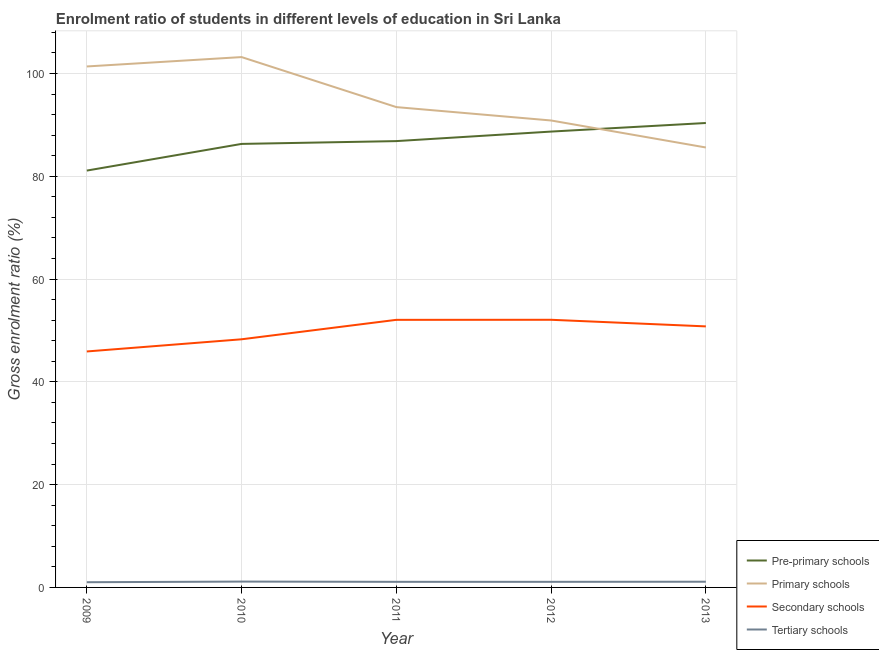Is the number of lines equal to the number of legend labels?
Provide a short and direct response. Yes. What is the gross enrolment ratio in pre-primary schools in 2013?
Keep it short and to the point. 90.36. Across all years, what is the maximum gross enrolment ratio in primary schools?
Make the answer very short. 103.19. Across all years, what is the minimum gross enrolment ratio in secondary schools?
Your answer should be compact. 45.91. In which year was the gross enrolment ratio in pre-primary schools maximum?
Offer a very short reply. 2013. What is the total gross enrolment ratio in secondary schools in the graph?
Give a very brief answer. 249.12. What is the difference between the gross enrolment ratio in primary schools in 2011 and that in 2012?
Keep it short and to the point. 2.6. What is the difference between the gross enrolment ratio in tertiary schools in 2011 and the gross enrolment ratio in pre-primary schools in 2013?
Offer a terse response. -89.27. What is the average gross enrolment ratio in primary schools per year?
Keep it short and to the point. 94.89. In the year 2011, what is the difference between the gross enrolment ratio in pre-primary schools and gross enrolment ratio in tertiary schools?
Keep it short and to the point. 85.75. What is the ratio of the gross enrolment ratio in pre-primary schools in 2010 to that in 2013?
Ensure brevity in your answer.  0.95. Is the gross enrolment ratio in primary schools in 2012 less than that in 2013?
Your response must be concise. No. What is the difference between the highest and the second highest gross enrolment ratio in tertiary schools?
Your answer should be very brief. 0.03. What is the difference between the highest and the lowest gross enrolment ratio in secondary schools?
Your response must be concise. 6.16. What is the difference between two consecutive major ticks on the Y-axis?
Provide a short and direct response. 20. Are the values on the major ticks of Y-axis written in scientific E-notation?
Provide a succinct answer. No. Does the graph contain any zero values?
Make the answer very short. No. Does the graph contain grids?
Provide a short and direct response. Yes. Where does the legend appear in the graph?
Give a very brief answer. Bottom right. How many legend labels are there?
Your response must be concise. 4. What is the title of the graph?
Ensure brevity in your answer.  Enrolment ratio of students in different levels of education in Sri Lanka. Does "Ease of arranging shipments" appear as one of the legend labels in the graph?
Offer a terse response. No. What is the label or title of the Y-axis?
Your answer should be compact. Gross enrolment ratio (%). What is the Gross enrolment ratio (%) in Pre-primary schools in 2009?
Make the answer very short. 81.1. What is the Gross enrolment ratio (%) of Primary schools in 2009?
Keep it short and to the point. 101.36. What is the Gross enrolment ratio (%) in Secondary schools in 2009?
Offer a very short reply. 45.91. What is the Gross enrolment ratio (%) in Tertiary schools in 2009?
Offer a terse response. 1.01. What is the Gross enrolment ratio (%) of Pre-primary schools in 2010?
Make the answer very short. 86.29. What is the Gross enrolment ratio (%) of Primary schools in 2010?
Ensure brevity in your answer.  103.19. What is the Gross enrolment ratio (%) in Secondary schools in 2010?
Give a very brief answer. 48.28. What is the Gross enrolment ratio (%) of Tertiary schools in 2010?
Provide a succinct answer. 1.14. What is the Gross enrolment ratio (%) of Pre-primary schools in 2011?
Ensure brevity in your answer.  86.84. What is the Gross enrolment ratio (%) in Primary schools in 2011?
Your response must be concise. 93.46. What is the Gross enrolment ratio (%) of Secondary schools in 2011?
Keep it short and to the point. 52.06. What is the Gross enrolment ratio (%) of Tertiary schools in 2011?
Provide a short and direct response. 1.09. What is the Gross enrolment ratio (%) of Pre-primary schools in 2012?
Offer a very short reply. 88.69. What is the Gross enrolment ratio (%) in Primary schools in 2012?
Your response must be concise. 90.85. What is the Gross enrolment ratio (%) of Secondary schools in 2012?
Make the answer very short. 52.08. What is the Gross enrolment ratio (%) in Tertiary schools in 2012?
Provide a short and direct response. 1.09. What is the Gross enrolment ratio (%) of Pre-primary schools in 2013?
Provide a short and direct response. 90.36. What is the Gross enrolment ratio (%) in Primary schools in 2013?
Your response must be concise. 85.6. What is the Gross enrolment ratio (%) in Secondary schools in 2013?
Give a very brief answer. 50.79. What is the Gross enrolment ratio (%) of Tertiary schools in 2013?
Give a very brief answer. 1.11. Across all years, what is the maximum Gross enrolment ratio (%) in Pre-primary schools?
Make the answer very short. 90.36. Across all years, what is the maximum Gross enrolment ratio (%) in Primary schools?
Your answer should be very brief. 103.19. Across all years, what is the maximum Gross enrolment ratio (%) in Secondary schools?
Offer a terse response. 52.08. Across all years, what is the maximum Gross enrolment ratio (%) in Tertiary schools?
Offer a very short reply. 1.14. Across all years, what is the minimum Gross enrolment ratio (%) in Pre-primary schools?
Offer a very short reply. 81.1. Across all years, what is the minimum Gross enrolment ratio (%) of Primary schools?
Ensure brevity in your answer.  85.6. Across all years, what is the minimum Gross enrolment ratio (%) in Secondary schools?
Make the answer very short. 45.91. Across all years, what is the minimum Gross enrolment ratio (%) in Tertiary schools?
Offer a very short reply. 1.01. What is the total Gross enrolment ratio (%) of Pre-primary schools in the graph?
Provide a succinct answer. 433.29. What is the total Gross enrolment ratio (%) of Primary schools in the graph?
Give a very brief answer. 474.45. What is the total Gross enrolment ratio (%) of Secondary schools in the graph?
Your answer should be very brief. 249.12. What is the total Gross enrolment ratio (%) of Tertiary schools in the graph?
Make the answer very short. 5.44. What is the difference between the Gross enrolment ratio (%) in Pre-primary schools in 2009 and that in 2010?
Your answer should be compact. -5.19. What is the difference between the Gross enrolment ratio (%) in Primary schools in 2009 and that in 2010?
Offer a terse response. -1.83. What is the difference between the Gross enrolment ratio (%) in Secondary schools in 2009 and that in 2010?
Your answer should be very brief. -2.37. What is the difference between the Gross enrolment ratio (%) in Tertiary schools in 2009 and that in 2010?
Your answer should be compact. -0.12. What is the difference between the Gross enrolment ratio (%) of Pre-primary schools in 2009 and that in 2011?
Keep it short and to the point. -5.73. What is the difference between the Gross enrolment ratio (%) in Primary schools in 2009 and that in 2011?
Keep it short and to the point. 7.91. What is the difference between the Gross enrolment ratio (%) in Secondary schools in 2009 and that in 2011?
Provide a short and direct response. -6.15. What is the difference between the Gross enrolment ratio (%) in Tertiary schools in 2009 and that in 2011?
Offer a terse response. -0.08. What is the difference between the Gross enrolment ratio (%) of Pre-primary schools in 2009 and that in 2012?
Provide a short and direct response. -7.59. What is the difference between the Gross enrolment ratio (%) of Primary schools in 2009 and that in 2012?
Offer a terse response. 10.51. What is the difference between the Gross enrolment ratio (%) in Secondary schools in 2009 and that in 2012?
Your answer should be very brief. -6.16. What is the difference between the Gross enrolment ratio (%) of Tertiary schools in 2009 and that in 2012?
Offer a terse response. -0.08. What is the difference between the Gross enrolment ratio (%) of Pre-primary schools in 2009 and that in 2013?
Give a very brief answer. -9.26. What is the difference between the Gross enrolment ratio (%) in Primary schools in 2009 and that in 2013?
Provide a short and direct response. 15.76. What is the difference between the Gross enrolment ratio (%) of Secondary schools in 2009 and that in 2013?
Ensure brevity in your answer.  -4.88. What is the difference between the Gross enrolment ratio (%) of Tertiary schools in 2009 and that in 2013?
Provide a short and direct response. -0.1. What is the difference between the Gross enrolment ratio (%) of Pre-primary schools in 2010 and that in 2011?
Give a very brief answer. -0.55. What is the difference between the Gross enrolment ratio (%) of Primary schools in 2010 and that in 2011?
Give a very brief answer. 9.73. What is the difference between the Gross enrolment ratio (%) in Secondary schools in 2010 and that in 2011?
Your response must be concise. -3.78. What is the difference between the Gross enrolment ratio (%) of Tertiary schools in 2010 and that in 2011?
Your answer should be very brief. 0.05. What is the difference between the Gross enrolment ratio (%) in Pre-primary schools in 2010 and that in 2012?
Your response must be concise. -2.4. What is the difference between the Gross enrolment ratio (%) in Primary schools in 2010 and that in 2012?
Provide a short and direct response. 12.34. What is the difference between the Gross enrolment ratio (%) in Secondary schools in 2010 and that in 2012?
Your response must be concise. -3.8. What is the difference between the Gross enrolment ratio (%) of Tertiary schools in 2010 and that in 2012?
Your response must be concise. 0.05. What is the difference between the Gross enrolment ratio (%) in Pre-primary schools in 2010 and that in 2013?
Your response must be concise. -4.07. What is the difference between the Gross enrolment ratio (%) in Primary schools in 2010 and that in 2013?
Offer a terse response. 17.59. What is the difference between the Gross enrolment ratio (%) in Secondary schools in 2010 and that in 2013?
Make the answer very short. -2.51. What is the difference between the Gross enrolment ratio (%) in Tertiary schools in 2010 and that in 2013?
Your answer should be compact. 0.03. What is the difference between the Gross enrolment ratio (%) of Pre-primary schools in 2011 and that in 2012?
Ensure brevity in your answer.  -1.85. What is the difference between the Gross enrolment ratio (%) of Primary schools in 2011 and that in 2012?
Provide a succinct answer. 2.6. What is the difference between the Gross enrolment ratio (%) of Secondary schools in 2011 and that in 2012?
Your response must be concise. -0.01. What is the difference between the Gross enrolment ratio (%) in Tertiary schools in 2011 and that in 2012?
Give a very brief answer. -0. What is the difference between the Gross enrolment ratio (%) in Pre-primary schools in 2011 and that in 2013?
Make the answer very short. -3.52. What is the difference between the Gross enrolment ratio (%) of Primary schools in 2011 and that in 2013?
Provide a short and direct response. 7.86. What is the difference between the Gross enrolment ratio (%) of Secondary schools in 2011 and that in 2013?
Ensure brevity in your answer.  1.27. What is the difference between the Gross enrolment ratio (%) of Tertiary schools in 2011 and that in 2013?
Provide a succinct answer. -0.02. What is the difference between the Gross enrolment ratio (%) in Pre-primary schools in 2012 and that in 2013?
Provide a succinct answer. -1.67. What is the difference between the Gross enrolment ratio (%) in Primary schools in 2012 and that in 2013?
Provide a succinct answer. 5.25. What is the difference between the Gross enrolment ratio (%) in Secondary schools in 2012 and that in 2013?
Keep it short and to the point. 1.29. What is the difference between the Gross enrolment ratio (%) in Tertiary schools in 2012 and that in 2013?
Your answer should be very brief. -0.02. What is the difference between the Gross enrolment ratio (%) in Pre-primary schools in 2009 and the Gross enrolment ratio (%) in Primary schools in 2010?
Your answer should be very brief. -22.08. What is the difference between the Gross enrolment ratio (%) in Pre-primary schools in 2009 and the Gross enrolment ratio (%) in Secondary schools in 2010?
Your answer should be compact. 32.83. What is the difference between the Gross enrolment ratio (%) in Pre-primary schools in 2009 and the Gross enrolment ratio (%) in Tertiary schools in 2010?
Your answer should be very brief. 79.97. What is the difference between the Gross enrolment ratio (%) of Primary schools in 2009 and the Gross enrolment ratio (%) of Secondary schools in 2010?
Offer a very short reply. 53.08. What is the difference between the Gross enrolment ratio (%) of Primary schools in 2009 and the Gross enrolment ratio (%) of Tertiary schools in 2010?
Provide a short and direct response. 100.22. What is the difference between the Gross enrolment ratio (%) of Secondary schools in 2009 and the Gross enrolment ratio (%) of Tertiary schools in 2010?
Provide a short and direct response. 44.77. What is the difference between the Gross enrolment ratio (%) in Pre-primary schools in 2009 and the Gross enrolment ratio (%) in Primary schools in 2011?
Make the answer very short. -12.35. What is the difference between the Gross enrolment ratio (%) of Pre-primary schools in 2009 and the Gross enrolment ratio (%) of Secondary schools in 2011?
Provide a succinct answer. 29.04. What is the difference between the Gross enrolment ratio (%) of Pre-primary schools in 2009 and the Gross enrolment ratio (%) of Tertiary schools in 2011?
Provide a succinct answer. 80.02. What is the difference between the Gross enrolment ratio (%) in Primary schools in 2009 and the Gross enrolment ratio (%) in Secondary schools in 2011?
Give a very brief answer. 49.3. What is the difference between the Gross enrolment ratio (%) of Primary schools in 2009 and the Gross enrolment ratio (%) of Tertiary schools in 2011?
Provide a short and direct response. 100.27. What is the difference between the Gross enrolment ratio (%) of Secondary schools in 2009 and the Gross enrolment ratio (%) of Tertiary schools in 2011?
Provide a succinct answer. 44.82. What is the difference between the Gross enrolment ratio (%) of Pre-primary schools in 2009 and the Gross enrolment ratio (%) of Primary schools in 2012?
Make the answer very short. -9.75. What is the difference between the Gross enrolment ratio (%) of Pre-primary schools in 2009 and the Gross enrolment ratio (%) of Secondary schools in 2012?
Provide a short and direct response. 29.03. What is the difference between the Gross enrolment ratio (%) of Pre-primary schools in 2009 and the Gross enrolment ratio (%) of Tertiary schools in 2012?
Offer a very short reply. 80.02. What is the difference between the Gross enrolment ratio (%) in Primary schools in 2009 and the Gross enrolment ratio (%) in Secondary schools in 2012?
Make the answer very short. 49.29. What is the difference between the Gross enrolment ratio (%) in Primary schools in 2009 and the Gross enrolment ratio (%) in Tertiary schools in 2012?
Offer a very short reply. 100.27. What is the difference between the Gross enrolment ratio (%) of Secondary schools in 2009 and the Gross enrolment ratio (%) of Tertiary schools in 2012?
Offer a very short reply. 44.82. What is the difference between the Gross enrolment ratio (%) in Pre-primary schools in 2009 and the Gross enrolment ratio (%) in Primary schools in 2013?
Keep it short and to the point. -4.49. What is the difference between the Gross enrolment ratio (%) of Pre-primary schools in 2009 and the Gross enrolment ratio (%) of Secondary schools in 2013?
Your answer should be compact. 30.32. What is the difference between the Gross enrolment ratio (%) of Pre-primary schools in 2009 and the Gross enrolment ratio (%) of Tertiary schools in 2013?
Your answer should be compact. 79.99. What is the difference between the Gross enrolment ratio (%) of Primary schools in 2009 and the Gross enrolment ratio (%) of Secondary schools in 2013?
Offer a very short reply. 50.57. What is the difference between the Gross enrolment ratio (%) in Primary schools in 2009 and the Gross enrolment ratio (%) in Tertiary schools in 2013?
Provide a short and direct response. 100.25. What is the difference between the Gross enrolment ratio (%) in Secondary schools in 2009 and the Gross enrolment ratio (%) in Tertiary schools in 2013?
Offer a very short reply. 44.8. What is the difference between the Gross enrolment ratio (%) of Pre-primary schools in 2010 and the Gross enrolment ratio (%) of Primary schools in 2011?
Give a very brief answer. -7.16. What is the difference between the Gross enrolment ratio (%) in Pre-primary schools in 2010 and the Gross enrolment ratio (%) in Secondary schools in 2011?
Offer a very short reply. 34.23. What is the difference between the Gross enrolment ratio (%) of Pre-primary schools in 2010 and the Gross enrolment ratio (%) of Tertiary schools in 2011?
Give a very brief answer. 85.21. What is the difference between the Gross enrolment ratio (%) in Primary schools in 2010 and the Gross enrolment ratio (%) in Secondary schools in 2011?
Your answer should be very brief. 51.12. What is the difference between the Gross enrolment ratio (%) of Primary schools in 2010 and the Gross enrolment ratio (%) of Tertiary schools in 2011?
Offer a very short reply. 102.1. What is the difference between the Gross enrolment ratio (%) in Secondary schools in 2010 and the Gross enrolment ratio (%) in Tertiary schools in 2011?
Your response must be concise. 47.19. What is the difference between the Gross enrolment ratio (%) of Pre-primary schools in 2010 and the Gross enrolment ratio (%) of Primary schools in 2012?
Provide a short and direct response. -4.56. What is the difference between the Gross enrolment ratio (%) of Pre-primary schools in 2010 and the Gross enrolment ratio (%) of Secondary schools in 2012?
Give a very brief answer. 34.22. What is the difference between the Gross enrolment ratio (%) in Pre-primary schools in 2010 and the Gross enrolment ratio (%) in Tertiary schools in 2012?
Your answer should be very brief. 85.2. What is the difference between the Gross enrolment ratio (%) of Primary schools in 2010 and the Gross enrolment ratio (%) of Secondary schools in 2012?
Keep it short and to the point. 51.11. What is the difference between the Gross enrolment ratio (%) of Primary schools in 2010 and the Gross enrolment ratio (%) of Tertiary schools in 2012?
Your answer should be compact. 102.1. What is the difference between the Gross enrolment ratio (%) of Secondary schools in 2010 and the Gross enrolment ratio (%) of Tertiary schools in 2012?
Give a very brief answer. 47.19. What is the difference between the Gross enrolment ratio (%) of Pre-primary schools in 2010 and the Gross enrolment ratio (%) of Primary schools in 2013?
Your response must be concise. 0.7. What is the difference between the Gross enrolment ratio (%) in Pre-primary schools in 2010 and the Gross enrolment ratio (%) in Secondary schools in 2013?
Your answer should be very brief. 35.5. What is the difference between the Gross enrolment ratio (%) in Pre-primary schools in 2010 and the Gross enrolment ratio (%) in Tertiary schools in 2013?
Your answer should be very brief. 85.18. What is the difference between the Gross enrolment ratio (%) of Primary schools in 2010 and the Gross enrolment ratio (%) of Secondary schools in 2013?
Your response must be concise. 52.4. What is the difference between the Gross enrolment ratio (%) in Primary schools in 2010 and the Gross enrolment ratio (%) in Tertiary schools in 2013?
Provide a short and direct response. 102.08. What is the difference between the Gross enrolment ratio (%) of Secondary schools in 2010 and the Gross enrolment ratio (%) of Tertiary schools in 2013?
Keep it short and to the point. 47.17. What is the difference between the Gross enrolment ratio (%) of Pre-primary schools in 2011 and the Gross enrolment ratio (%) of Primary schools in 2012?
Provide a short and direct response. -4.01. What is the difference between the Gross enrolment ratio (%) in Pre-primary schools in 2011 and the Gross enrolment ratio (%) in Secondary schools in 2012?
Offer a very short reply. 34.76. What is the difference between the Gross enrolment ratio (%) of Pre-primary schools in 2011 and the Gross enrolment ratio (%) of Tertiary schools in 2012?
Ensure brevity in your answer.  85.75. What is the difference between the Gross enrolment ratio (%) in Primary schools in 2011 and the Gross enrolment ratio (%) in Secondary schools in 2012?
Ensure brevity in your answer.  41.38. What is the difference between the Gross enrolment ratio (%) in Primary schools in 2011 and the Gross enrolment ratio (%) in Tertiary schools in 2012?
Offer a very short reply. 92.37. What is the difference between the Gross enrolment ratio (%) in Secondary schools in 2011 and the Gross enrolment ratio (%) in Tertiary schools in 2012?
Provide a short and direct response. 50.97. What is the difference between the Gross enrolment ratio (%) of Pre-primary schools in 2011 and the Gross enrolment ratio (%) of Primary schools in 2013?
Ensure brevity in your answer.  1.24. What is the difference between the Gross enrolment ratio (%) of Pre-primary schools in 2011 and the Gross enrolment ratio (%) of Secondary schools in 2013?
Your response must be concise. 36.05. What is the difference between the Gross enrolment ratio (%) of Pre-primary schools in 2011 and the Gross enrolment ratio (%) of Tertiary schools in 2013?
Ensure brevity in your answer.  85.73. What is the difference between the Gross enrolment ratio (%) of Primary schools in 2011 and the Gross enrolment ratio (%) of Secondary schools in 2013?
Keep it short and to the point. 42.67. What is the difference between the Gross enrolment ratio (%) of Primary schools in 2011 and the Gross enrolment ratio (%) of Tertiary schools in 2013?
Provide a succinct answer. 92.34. What is the difference between the Gross enrolment ratio (%) in Secondary schools in 2011 and the Gross enrolment ratio (%) in Tertiary schools in 2013?
Provide a succinct answer. 50.95. What is the difference between the Gross enrolment ratio (%) of Pre-primary schools in 2012 and the Gross enrolment ratio (%) of Primary schools in 2013?
Provide a succinct answer. 3.1. What is the difference between the Gross enrolment ratio (%) of Pre-primary schools in 2012 and the Gross enrolment ratio (%) of Secondary schools in 2013?
Your answer should be compact. 37.9. What is the difference between the Gross enrolment ratio (%) in Pre-primary schools in 2012 and the Gross enrolment ratio (%) in Tertiary schools in 2013?
Provide a succinct answer. 87.58. What is the difference between the Gross enrolment ratio (%) in Primary schools in 2012 and the Gross enrolment ratio (%) in Secondary schools in 2013?
Your answer should be very brief. 40.06. What is the difference between the Gross enrolment ratio (%) in Primary schools in 2012 and the Gross enrolment ratio (%) in Tertiary schools in 2013?
Give a very brief answer. 89.74. What is the difference between the Gross enrolment ratio (%) of Secondary schools in 2012 and the Gross enrolment ratio (%) of Tertiary schools in 2013?
Make the answer very short. 50.96. What is the average Gross enrolment ratio (%) in Pre-primary schools per year?
Provide a succinct answer. 86.66. What is the average Gross enrolment ratio (%) in Primary schools per year?
Provide a succinct answer. 94.89. What is the average Gross enrolment ratio (%) of Secondary schools per year?
Your answer should be very brief. 49.82. What is the average Gross enrolment ratio (%) of Tertiary schools per year?
Ensure brevity in your answer.  1.09. In the year 2009, what is the difference between the Gross enrolment ratio (%) in Pre-primary schools and Gross enrolment ratio (%) in Primary schools?
Provide a succinct answer. -20.26. In the year 2009, what is the difference between the Gross enrolment ratio (%) of Pre-primary schools and Gross enrolment ratio (%) of Secondary schools?
Offer a very short reply. 35.19. In the year 2009, what is the difference between the Gross enrolment ratio (%) of Pre-primary schools and Gross enrolment ratio (%) of Tertiary schools?
Ensure brevity in your answer.  80.09. In the year 2009, what is the difference between the Gross enrolment ratio (%) in Primary schools and Gross enrolment ratio (%) in Secondary schools?
Offer a very short reply. 55.45. In the year 2009, what is the difference between the Gross enrolment ratio (%) of Primary schools and Gross enrolment ratio (%) of Tertiary schools?
Ensure brevity in your answer.  100.35. In the year 2009, what is the difference between the Gross enrolment ratio (%) of Secondary schools and Gross enrolment ratio (%) of Tertiary schools?
Ensure brevity in your answer.  44.9. In the year 2010, what is the difference between the Gross enrolment ratio (%) of Pre-primary schools and Gross enrolment ratio (%) of Primary schools?
Provide a succinct answer. -16.89. In the year 2010, what is the difference between the Gross enrolment ratio (%) of Pre-primary schools and Gross enrolment ratio (%) of Secondary schools?
Your answer should be compact. 38.01. In the year 2010, what is the difference between the Gross enrolment ratio (%) of Pre-primary schools and Gross enrolment ratio (%) of Tertiary schools?
Provide a succinct answer. 85.16. In the year 2010, what is the difference between the Gross enrolment ratio (%) of Primary schools and Gross enrolment ratio (%) of Secondary schools?
Your answer should be compact. 54.91. In the year 2010, what is the difference between the Gross enrolment ratio (%) in Primary schools and Gross enrolment ratio (%) in Tertiary schools?
Give a very brief answer. 102.05. In the year 2010, what is the difference between the Gross enrolment ratio (%) in Secondary schools and Gross enrolment ratio (%) in Tertiary schools?
Your answer should be compact. 47.14. In the year 2011, what is the difference between the Gross enrolment ratio (%) in Pre-primary schools and Gross enrolment ratio (%) in Primary schools?
Your answer should be very brief. -6.62. In the year 2011, what is the difference between the Gross enrolment ratio (%) in Pre-primary schools and Gross enrolment ratio (%) in Secondary schools?
Provide a succinct answer. 34.78. In the year 2011, what is the difference between the Gross enrolment ratio (%) of Pre-primary schools and Gross enrolment ratio (%) of Tertiary schools?
Provide a short and direct response. 85.75. In the year 2011, what is the difference between the Gross enrolment ratio (%) of Primary schools and Gross enrolment ratio (%) of Secondary schools?
Ensure brevity in your answer.  41.39. In the year 2011, what is the difference between the Gross enrolment ratio (%) of Primary schools and Gross enrolment ratio (%) of Tertiary schools?
Ensure brevity in your answer.  92.37. In the year 2011, what is the difference between the Gross enrolment ratio (%) of Secondary schools and Gross enrolment ratio (%) of Tertiary schools?
Offer a terse response. 50.97. In the year 2012, what is the difference between the Gross enrolment ratio (%) in Pre-primary schools and Gross enrolment ratio (%) in Primary schools?
Provide a succinct answer. -2.16. In the year 2012, what is the difference between the Gross enrolment ratio (%) in Pre-primary schools and Gross enrolment ratio (%) in Secondary schools?
Your response must be concise. 36.62. In the year 2012, what is the difference between the Gross enrolment ratio (%) in Pre-primary schools and Gross enrolment ratio (%) in Tertiary schools?
Your answer should be compact. 87.6. In the year 2012, what is the difference between the Gross enrolment ratio (%) of Primary schools and Gross enrolment ratio (%) of Secondary schools?
Make the answer very short. 38.78. In the year 2012, what is the difference between the Gross enrolment ratio (%) of Primary schools and Gross enrolment ratio (%) of Tertiary schools?
Give a very brief answer. 89.76. In the year 2012, what is the difference between the Gross enrolment ratio (%) of Secondary schools and Gross enrolment ratio (%) of Tertiary schools?
Provide a succinct answer. 50.99. In the year 2013, what is the difference between the Gross enrolment ratio (%) in Pre-primary schools and Gross enrolment ratio (%) in Primary schools?
Ensure brevity in your answer.  4.76. In the year 2013, what is the difference between the Gross enrolment ratio (%) of Pre-primary schools and Gross enrolment ratio (%) of Secondary schools?
Your answer should be compact. 39.57. In the year 2013, what is the difference between the Gross enrolment ratio (%) in Pre-primary schools and Gross enrolment ratio (%) in Tertiary schools?
Provide a succinct answer. 89.25. In the year 2013, what is the difference between the Gross enrolment ratio (%) in Primary schools and Gross enrolment ratio (%) in Secondary schools?
Offer a terse response. 34.81. In the year 2013, what is the difference between the Gross enrolment ratio (%) in Primary schools and Gross enrolment ratio (%) in Tertiary schools?
Your answer should be compact. 84.49. In the year 2013, what is the difference between the Gross enrolment ratio (%) of Secondary schools and Gross enrolment ratio (%) of Tertiary schools?
Your answer should be compact. 49.68. What is the ratio of the Gross enrolment ratio (%) in Pre-primary schools in 2009 to that in 2010?
Offer a very short reply. 0.94. What is the ratio of the Gross enrolment ratio (%) of Primary schools in 2009 to that in 2010?
Provide a succinct answer. 0.98. What is the ratio of the Gross enrolment ratio (%) of Secondary schools in 2009 to that in 2010?
Give a very brief answer. 0.95. What is the ratio of the Gross enrolment ratio (%) in Tertiary schools in 2009 to that in 2010?
Provide a succinct answer. 0.89. What is the ratio of the Gross enrolment ratio (%) in Pre-primary schools in 2009 to that in 2011?
Ensure brevity in your answer.  0.93. What is the ratio of the Gross enrolment ratio (%) of Primary schools in 2009 to that in 2011?
Your answer should be compact. 1.08. What is the ratio of the Gross enrolment ratio (%) of Secondary schools in 2009 to that in 2011?
Keep it short and to the point. 0.88. What is the ratio of the Gross enrolment ratio (%) of Tertiary schools in 2009 to that in 2011?
Offer a terse response. 0.93. What is the ratio of the Gross enrolment ratio (%) of Pre-primary schools in 2009 to that in 2012?
Provide a short and direct response. 0.91. What is the ratio of the Gross enrolment ratio (%) of Primary schools in 2009 to that in 2012?
Offer a terse response. 1.12. What is the ratio of the Gross enrolment ratio (%) in Secondary schools in 2009 to that in 2012?
Keep it short and to the point. 0.88. What is the ratio of the Gross enrolment ratio (%) of Tertiary schools in 2009 to that in 2012?
Give a very brief answer. 0.93. What is the ratio of the Gross enrolment ratio (%) of Pre-primary schools in 2009 to that in 2013?
Keep it short and to the point. 0.9. What is the ratio of the Gross enrolment ratio (%) of Primary schools in 2009 to that in 2013?
Your answer should be compact. 1.18. What is the ratio of the Gross enrolment ratio (%) in Secondary schools in 2009 to that in 2013?
Offer a terse response. 0.9. What is the ratio of the Gross enrolment ratio (%) of Tertiary schools in 2009 to that in 2013?
Your response must be concise. 0.91. What is the ratio of the Gross enrolment ratio (%) of Primary schools in 2010 to that in 2011?
Provide a short and direct response. 1.1. What is the ratio of the Gross enrolment ratio (%) in Secondary schools in 2010 to that in 2011?
Your answer should be very brief. 0.93. What is the ratio of the Gross enrolment ratio (%) in Tertiary schools in 2010 to that in 2011?
Your answer should be compact. 1.04. What is the ratio of the Gross enrolment ratio (%) of Pre-primary schools in 2010 to that in 2012?
Your answer should be compact. 0.97. What is the ratio of the Gross enrolment ratio (%) of Primary schools in 2010 to that in 2012?
Your answer should be very brief. 1.14. What is the ratio of the Gross enrolment ratio (%) of Secondary schools in 2010 to that in 2012?
Offer a terse response. 0.93. What is the ratio of the Gross enrolment ratio (%) of Tertiary schools in 2010 to that in 2012?
Offer a terse response. 1.04. What is the ratio of the Gross enrolment ratio (%) in Pre-primary schools in 2010 to that in 2013?
Make the answer very short. 0.95. What is the ratio of the Gross enrolment ratio (%) in Primary schools in 2010 to that in 2013?
Your answer should be compact. 1.21. What is the ratio of the Gross enrolment ratio (%) in Secondary schools in 2010 to that in 2013?
Keep it short and to the point. 0.95. What is the ratio of the Gross enrolment ratio (%) of Tertiary schools in 2010 to that in 2013?
Your answer should be compact. 1.02. What is the ratio of the Gross enrolment ratio (%) of Pre-primary schools in 2011 to that in 2012?
Offer a very short reply. 0.98. What is the ratio of the Gross enrolment ratio (%) in Primary schools in 2011 to that in 2012?
Offer a terse response. 1.03. What is the ratio of the Gross enrolment ratio (%) in Secondary schools in 2011 to that in 2012?
Make the answer very short. 1. What is the ratio of the Gross enrolment ratio (%) of Tertiary schools in 2011 to that in 2012?
Your answer should be very brief. 1. What is the ratio of the Gross enrolment ratio (%) in Primary schools in 2011 to that in 2013?
Provide a succinct answer. 1.09. What is the ratio of the Gross enrolment ratio (%) of Secondary schools in 2011 to that in 2013?
Offer a very short reply. 1.03. What is the ratio of the Gross enrolment ratio (%) in Tertiary schools in 2011 to that in 2013?
Your answer should be compact. 0.98. What is the ratio of the Gross enrolment ratio (%) in Pre-primary schools in 2012 to that in 2013?
Provide a short and direct response. 0.98. What is the ratio of the Gross enrolment ratio (%) in Primary schools in 2012 to that in 2013?
Offer a very short reply. 1.06. What is the ratio of the Gross enrolment ratio (%) in Secondary schools in 2012 to that in 2013?
Keep it short and to the point. 1.03. What is the ratio of the Gross enrolment ratio (%) in Tertiary schools in 2012 to that in 2013?
Your response must be concise. 0.98. What is the difference between the highest and the second highest Gross enrolment ratio (%) in Pre-primary schools?
Your response must be concise. 1.67. What is the difference between the highest and the second highest Gross enrolment ratio (%) of Primary schools?
Your answer should be compact. 1.83. What is the difference between the highest and the second highest Gross enrolment ratio (%) of Secondary schools?
Your response must be concise. 0.01. What is the difference between the highest and the second highest Gross enrolment ratio (%) of Tertiary schools?
Offer a terse response. 0.03. What is the difference between the highest and the lowest Gross enrolment ratio (%) in Pre-primary schools?
Offer a terse response. 9.26. What is the difference between the highest and the lowest Gross enrolment ratio (%) in Primary schools?
Make the answer very short. 17.59. What is the difference between the highest and the lowest Gross enrolment ratio (%) in Secondary schools?
Your response must be concise. 6.16. What is the difference between the highest and the lowest Gross enrolment ratio (%) in Tertiary schools?
Your answer should be very brief. 0.12. 